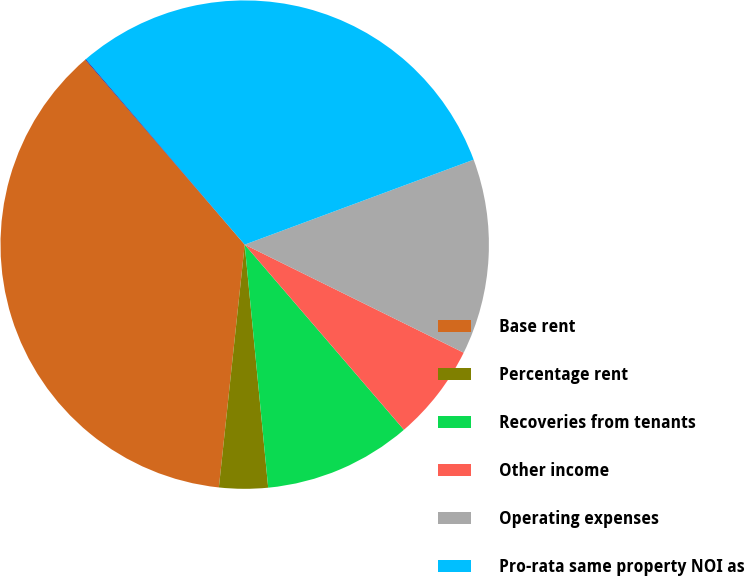Convert chart to OTSL. <chart><loc_0><loc_0><loc_500><loc_500><pie_chart><fcel>Base rent<fcel>Percentage rent<fcel>Recoveries from tenants<fcel>Other income<fcel>Operating expenses<fcel>Pro-rata same property NOI as<fcel>Less Termination fees<nl><fcel>36.99%<fcel>3.22%<fcel>9.77%<fcel>6.4%<fcel>12.95%<fcel>30.63%<fcel>0.04%<nl></chart> 